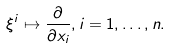<formula> <loc_0><loc_0><loc_500><loc_500>\xi ^ { i } \mapsto \frac { \partial } { \partial x _ { i } } , i = 1 , \dots , n .</formula> 